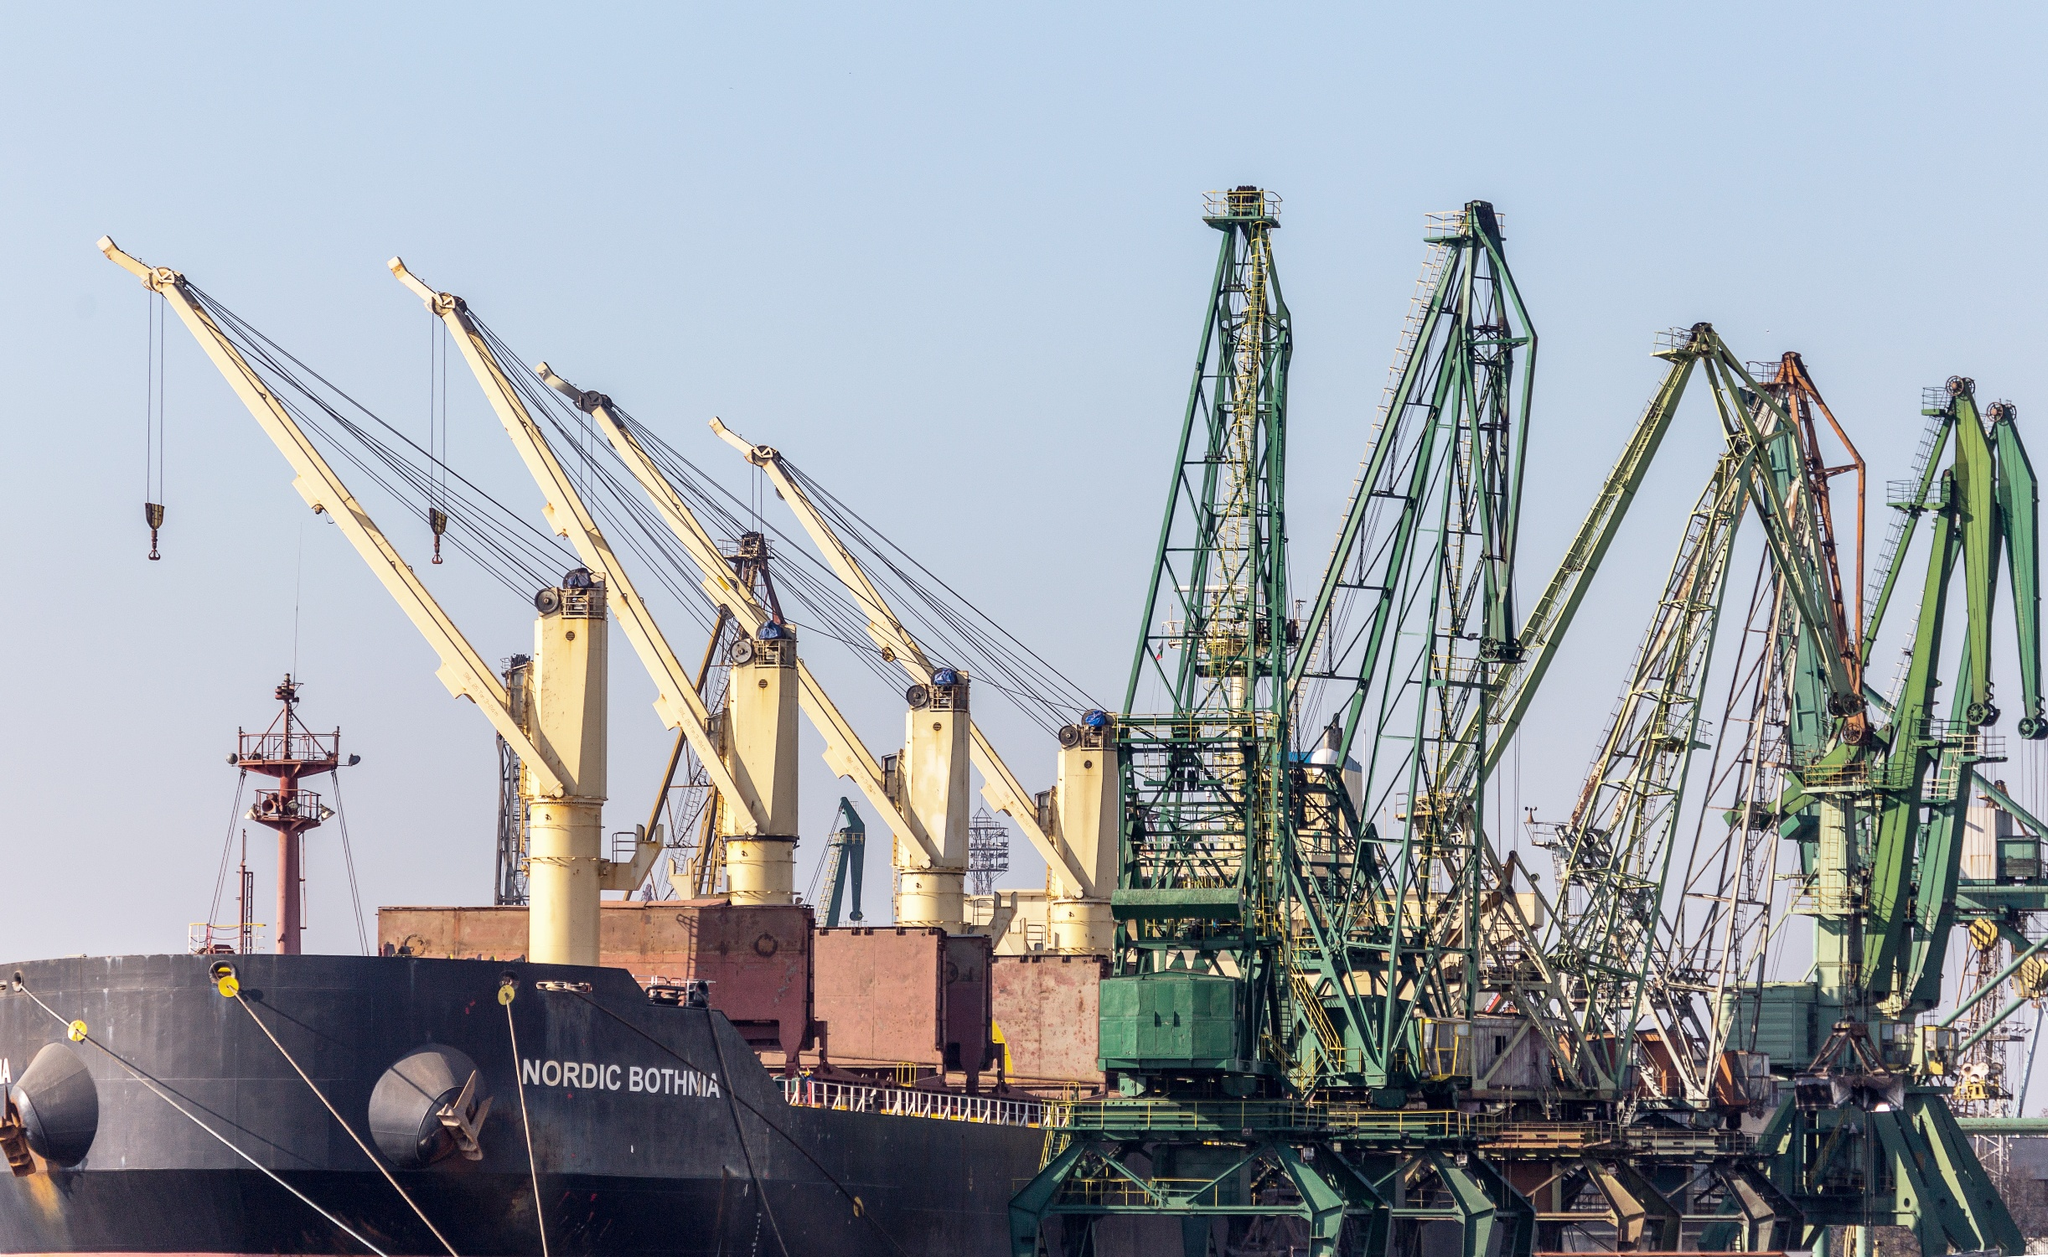How does the crane system work in loading cargo onto ships? The cranes used in ports for loading cargo onto ships like the 'Nordic Bothnia' are typically gantry cranes with a sophisticated mechanism. They are operated by skilled technicians who control the movement of cargo using joysticks or computer systems. The cranes can lift heavy containers or bulk cargo from the dockside, swing them over the water, and accurately place them on the deck of the ship, maximizing efficiency and safety. 